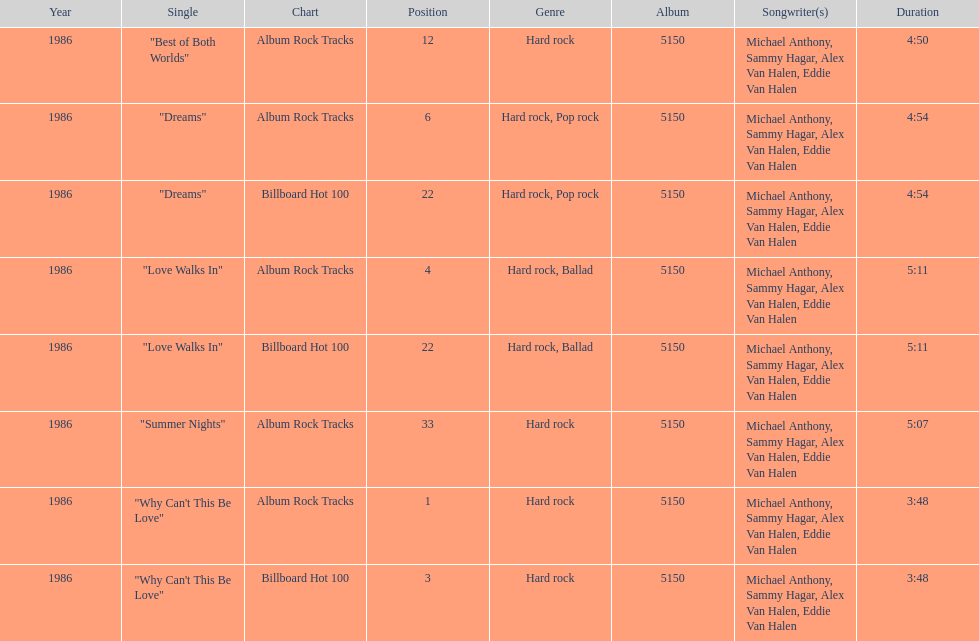Which is the most popular single on the album? Why Can't This Be Love. 